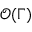<formula> <loc_0><loc_0><loc_500><loc_500>\mathcal { O } ( \Gamma )</formula> 